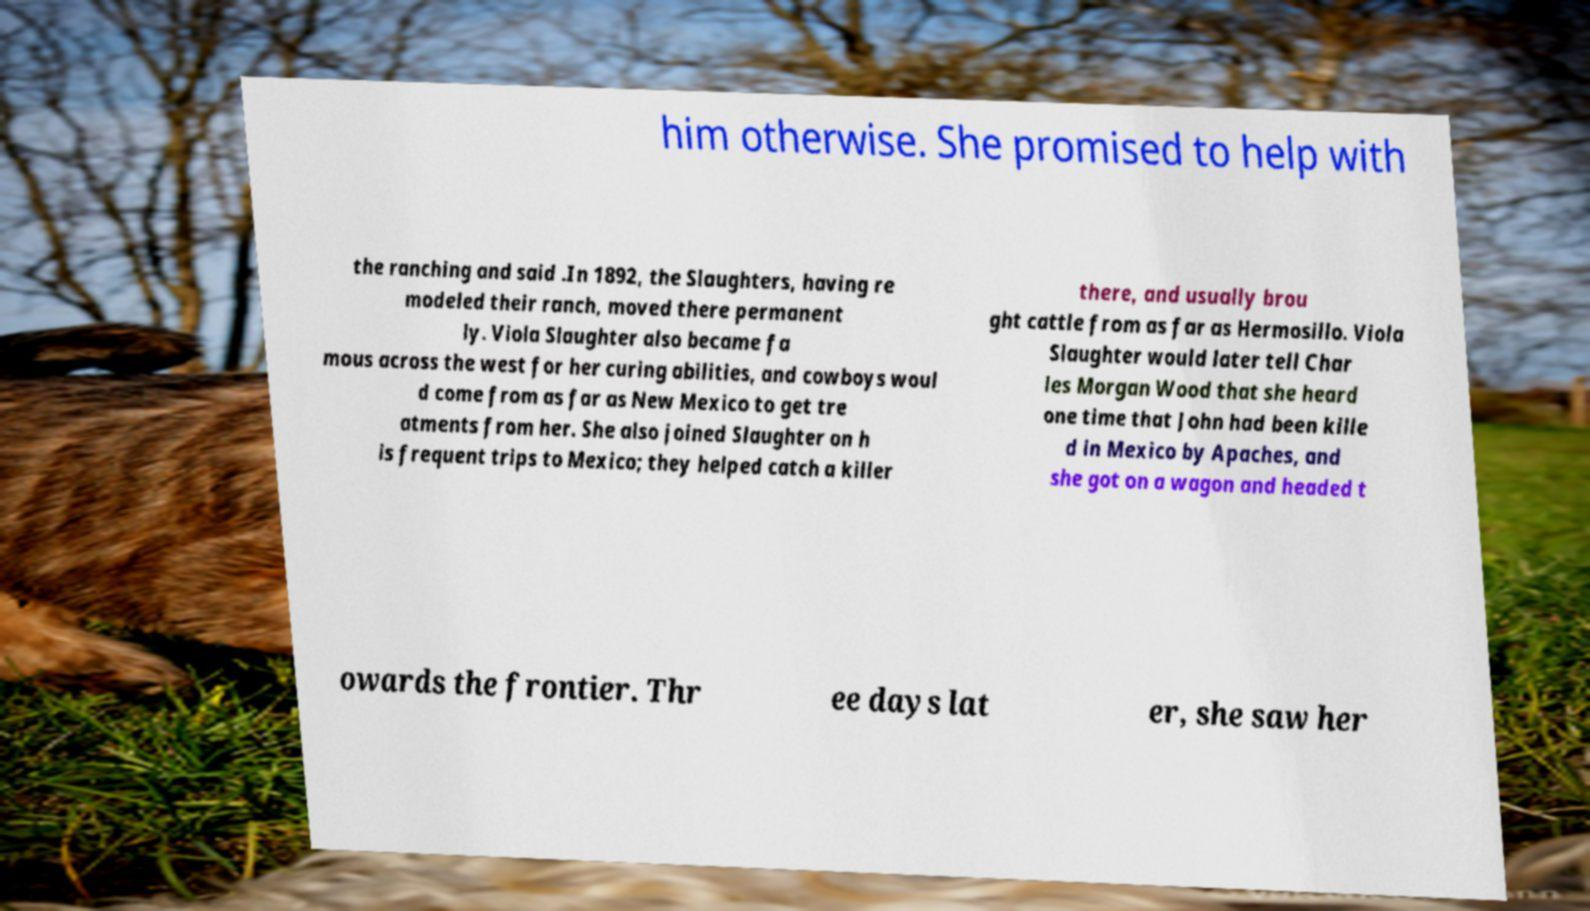What messages or text are displayed in this image? I need them in a readable, typed format. him otherwise. She promised to help with the ranching and said .In 1892, the Slaughters, having re modeled their ranch, moved there permanent ly. Viola Slaughter also became fa mous across the west for her curing abilities, and cowboys woul d come from as far as New Mexico to get tre atments from her. She also joined Slaughter on h is frequent trips to Mexico; they helped catch a killer there, and usually brou ght cattle from as far as Hermosillo. Viola Slaughter would later tell Char les Morgan Wood that she heard one time that John had been kille d in Mexico by Apaches, and she got on a wagon and headed t owards the frontier. Thr ee days lat er, she saw her 